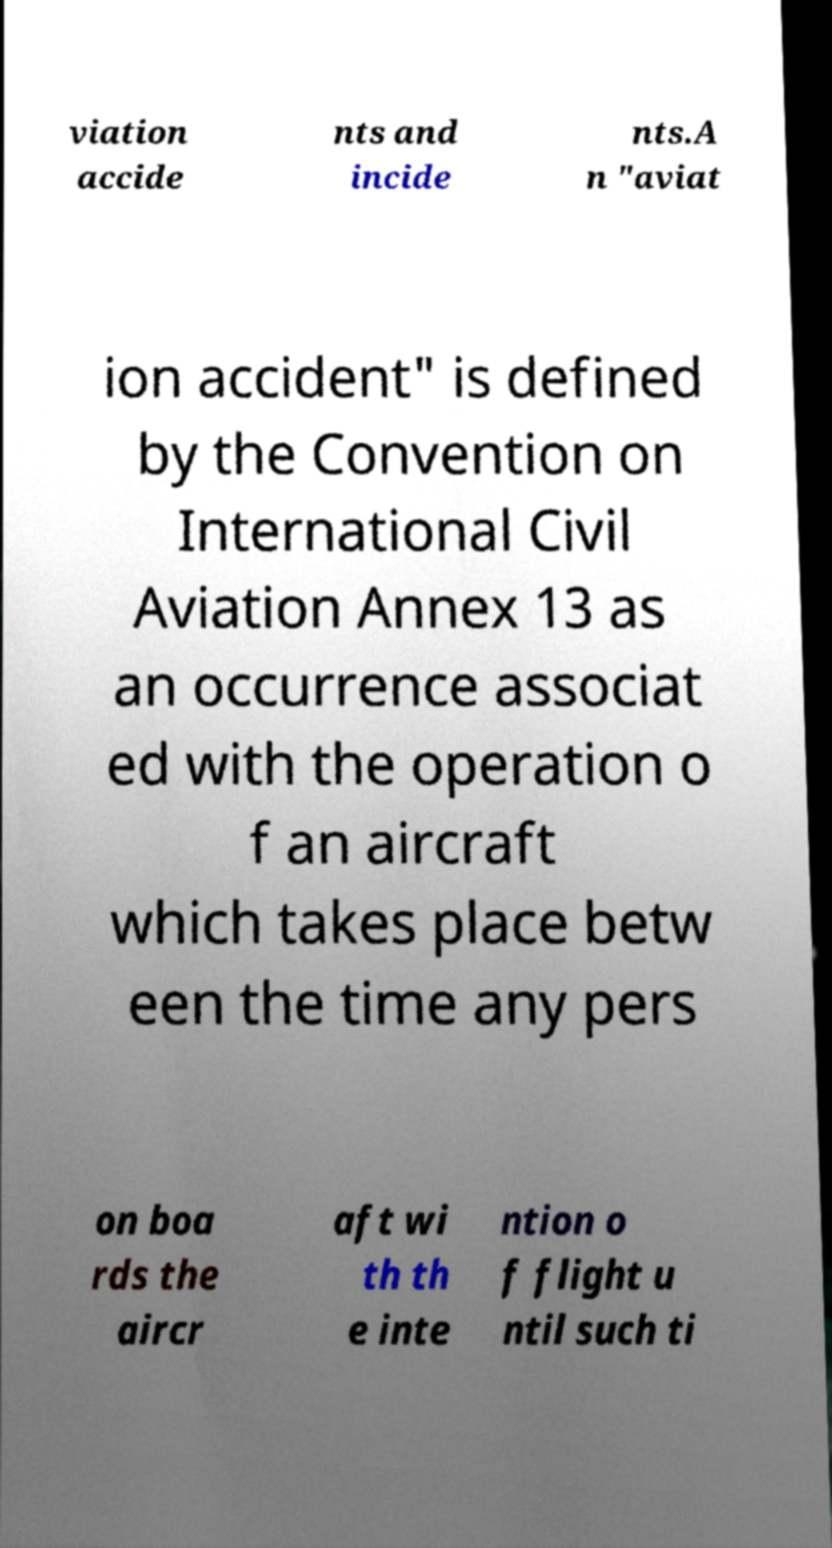Can you read and provide the text displayed in the image?This photo seems to have some interesting text. Can you extract and type it out for me? viation accide nts and incide nts.A n "aviat ion accident" is defined by the Convention on International Civil Aviation Annex 13 as an occurrence associat ed with the operation o f an aircraft which takes place betw een the time any pers on boa rds the aircr aft wi th th e inte ntion o f flight u ntil such ti 